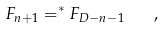Convert formula to latex. <formula><loc_0><loc_0><loc_500><loc_500>F _ { n + 1 } = ^ { * } F _ { D - n - 1 } \quad ,</formula> 